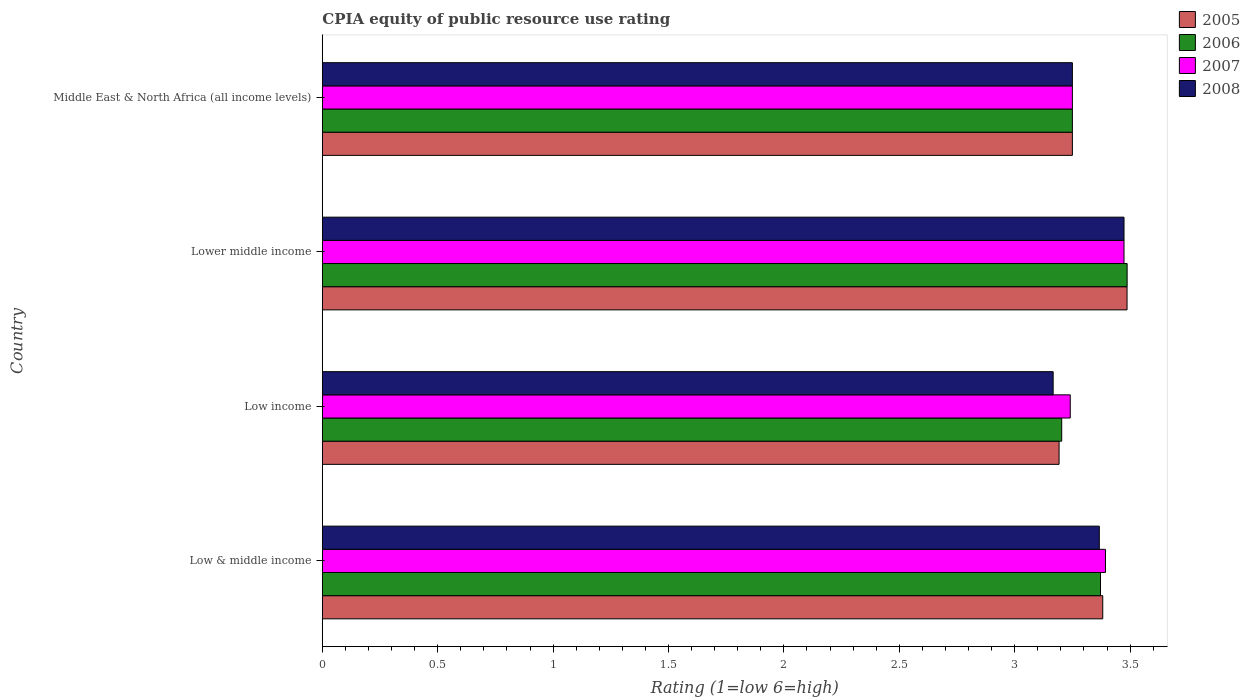How many groups of bars are there?
Provide a short and direct response. 4. Are the number of bars per tick equal to the number of legend labels?
Your answer should be compact. Yes. Are the number of bars on each tick of the Y-axis equal?
Ensure brevity in your answer.  Yes. How many bars are there on the 1st tick from the top?
Keep it short and to the point. 4. How many bars are there on the 3rd tick from the bottom?
Your answer should be very brief. 4. What is the label of the 4th group of bars from the top?
Ensure brevity in your answer.  Low & middle income. In how many cases, is the number of bars for a given country not equal to the number of legend labels?
Keep it short and to the point. 0. Across all countries, what is the maximum CPIA rating in 2007?
Your response must be concise. 3.47. Across all countries, what is the minimum CPIA rating in 2005?
Give a very brief answer. 3.19. In which country was the CPIA rating in 2006 maximum?
Keep it short and to the point. Lower middle income. What is the total CPIA rating in 2008 in the graph?
Provide a short and direct response. 13.26. What is the difference between the CPIA rating in 2006 in Lower middle income and that in Middle East & North Africa (all income levels)?
Make the answer very short. 0.24. What is the difference between the CPIA rating in 2005 in Lower middle income and the CPIA rating in 2006 in Low & middle income?
Keep it short and to the point. 0.12. What is the average CPIA rating in 2005 per country?
Ensure brevity in your answer.  3.33. What is the difference between the CPIA rating in 2008 and CPIA rating in 2006 in Low & middle income?
Keep it short and to the point. -0.01. What is the ratio of the CPIA rating in 2005 in Lower middle income to that in Middle East & North Africa (all income levels)?
Keep it short and to the point. 1.07. What is the difference between the highest and the second highest CPIA rating in 2007?
Provide a short and direct response. 0.08. What is the difference between the highest and the lowest CPIA rating in 2006?
Ensure brevity in your answer.  0.28. In how many countries, is the CPIA rating in 2008 greater than the average CPIA rating in 2008 taken over all countries?
Provide a short and direct response. 2. Is it the case that in every country, the sum of the CPIA rating in 2006 and CPIA rating in 2005 is greater than the sum of CPIA rating in 2007 and CPIA rating in 2008?
Offer a terse response. No. How many bars are there?
Ensure brevity in your answer.  16. What is the difference between two consecutive major ticks on the X-axis?
Your answer should be very brief. 0.5. Are the values on the major ticks of X-axis written in scientific E-notation?
Provide a succinct answer. No. Does the graph contain any zero values?
Your answer should be compact. No. Does the graph contain grids?
Make the answer very short. No. How are the legend labels stacked?
Provide a short and direct response. Vertical. What is the title of the graph?
Provide a short and direct response. CPIA equity of public resource use rating. Does "1979" appear as one of the legend labels in the graph?
Provide a succinct answer. No. What is the Rating (1=low 6=high) in 2005 in Low & middle income?
Give a very brief answer. 3.38. What is the Rating (1=low 6=high) in 2006 in Low & middle income?
Your response must be concise. 3.37. What is the Rating (1=low 6=high) of 2007 in Low & middle income?
Give a very brief answer. 3.39. What is the Rating (1=low 6=high) in 2008 in Low & middle income?
Your response must be concise. 3.37. What is the Rating (1=low 6=high) in 2005 in Low income?
Provide a succinct answer. 3.19. What is the Rating (1=low 6=high) in 2006 in Low income?
Offer a very short reply. 3.2. What is the Rating (1=low 6=high) of 2007 in Low income?
Provide a succinct answer. 3.24. What is the Rating (1=low 6=high) in 2008 in Low income?
Keep it short and to the point. 3.17. What is the Rating (1=low 6=high) in 2005 in Lower middle income?
Give a very brief answer. 3.49. What is the Rating (1=low 6=high) in 2006 in Lower middle income?
Ensure brevity in your answer.  3.49. What is the Rating (1=low 6=high) in 2007 in Lower middle income?
Offer a terse response. 3.47. What is the Rating (1=low 6=high) in 2008 in Lower middle income?
Make the answer very short. 3.47. What is the Rating (1=low 6=high) of 2005 in Middle East & North Africa (all income levels)?
Provide a short and direct response. 3.25. What is the Rating (1=low 6=high) in 2007 in Middle East & North Africa (all income levels)?
Provide a short and direct response. 3.25. Across all countries, what is the maximum Rating (1=low 6=high) in 2005?
Your answer should be very brief. 3.49. Across all countries, what is the maximum Rating (1=low 6=high) of 2006?
Offer a very short reply. 3.49. Across all countries, what is the maximum Rating (1=low 6=high) of 2007?
Offer a terse response. 3.47. Across all countries, what is the maximum Rating (1=low 6=high) in 2008?
Offer a terse response. 3.47. Across all countries, what is the minimum Rating (1=low 6=high) of 2005?
Give a very brief answer. 3.19. Across all countries, what is the minimum Rating (1=low 6=high) of 2006?
Give a very brief answer. 3.2. Across all countries, what is the minimum Rating (1=low 6=high) of 2007?
Your answer should be compact. 3.24. Across all countries, what is the minimum Rating (1=low 6=high) in 2008?
Offer a very short reply. 3.17. What is the total Rating (1=low 6=high) of 2005 in the graph?
Ensure brevity in your answer.  13.31. What is the total Rating (1=low 6=high) of 2006 in the graph?
Your answer should be compact. 13.31. What is the total Rating (1=low 6=high) of 2007 in the graph?
Offer a terse response. 13.36. What is the total Rating (1=low 6=high) of 2008 in the graph?
Offer a very short reply. 13.26. What is the difference between the Rating (1=low 6=high) of 2005 in Low & middle income and that in Low income?
Keep it short and to the point. 0.19. What is the difference between the Rating (1=low 6=high) in 2006 in Low & middle income and that in Low income?
Keep it short and to the point. 0.17. What is the difference between the Rating (1=low 6=high) in 2007 in Low & middle income and that in Low income?
Offer a terse response. 0.15. What is the difference between the Rating (1=low 6=high) of 2005 in Low & middle income and that in Lower middle income?
Offer a terse response. -0.11. What is the difference between the Rating (1=low 6=high) in 2006 in Low & middle income and that in Lower middle income?
Offer a terse response. -0.12. What is the difference between the Rating (1=low 6=high) of 2007 in Low & middle income and that in Lower middle income?
Make the answer very short. -0.08. What is the difference between the Rating (1=low 6=high) of 2008 in Low & middle income and that in Lower middle income?
Give a very brief answer. -0.11. What is the difference between the Rating (1=low 6=high) in 2005 in Low & middle income and that in Middle East & North Africa (all income levels)?
Offer a very short reply. 0.13. What is the difference between the Rating (1=low 6=high) in 2006 in Low & middle income and that in Middle East & North Africa (all income levels)?
Offer a terse response. 0.12. What is the difference between the Rating (1=low 6=high) of 2007 in Low & middle income and that in Middle East & North Africa (all income levels)?
Provide a succinct answer. 0.14. What is the difference between the Rating (1=low 6=high) of 2008 in Low & middle income and that in Middle East & North Africa (all income levels)?
Offer a terse response. 0.12. What is the difference between the Rating (1=low 6=high) in 2005 in Low income and that in Lower middle income?
Give a very brief answer. -0.29. What is the difference between the Rating (1=low 6=high) in 2006 in Low income and that in Lower middle income?
Make the answer very short. -0.28. What is the difference between the Rating (1=low 6=high) in 2007 in Low income and that in Lower middle income?
Provide a succinct answer. -0.23. What is the difference between the Rating (1=low 6=high) of 2008 in Low income and that in Lower middle income?
Your answer should be compact. -0.31. What is the difference between the Rating (1=low 6=high) in 2005 in Low income and that in Middle East & North Africa (all income levels)?
Offer a very short reply. -0.06. What is the difference between the Rating (1=low 6=high) of 2006 in Low income and that in Middle East & North Africa (all income levels)?
Ensure brevity in your answer.  -0.05. What is the difference between the Rating (1=low 6=high) in 2007 in Low income and that in Middle East & North Africa (all income levels)?
Provide a short and direct response. -0.01. What is the difference between the Rating (1=low 6=high) of 2008 in Low income and that in Middle East & North Africa (all income levels)?
Keep it short and to the point. -0.08. What is the difference between the Rating (1=low 6=high) in 2005 in Lower middle income and that in Middle East & North Africa (all income levels)?
Your response must be concise. 0.24. What is the difference between the Rating (1=low 6=high) of 2006 in Lower middle income and that in Middle East & North Africa (all income levels)?
Offer a terse response. 0.24. What is the difference between the Rating (1=low 6=high) of 2007 in Lower middle income and that in Middle East & North Africa (all income levels)?
Your answer should be compact. 0.22. What is the difference between the Rating (1=low 6=high) in 2008 in Lower middle income and that in Middle East & North Africa (all income levels)?
Provide a short and direct response. 0.22. What is the difference between the Rating (1=low 6=high) in 2005 in Low & middle income and the Rating (1=low 6=high) in 2006 in Low income?
Give a very brief answer. 0.18. What is the difference between the Rating (1=low 6=high) in 2005 in Low & middle income and the Rating (1=low 6=high) in 2007 in Low income?
Give a very brief answer. 0.14. What is the difference between the Rating (1=low 6=high) of 2005 in Low & middle income and the Rating (1=low 6=high) of 2008 in Low income?
Your answer should be compact. 0.21. What is the difference between the Rating (1=low 6=high) of 2006 in Low & middle income and the Rating (1=low 6=high) of 2007 in Low income?
Make the answer very short. 0.13. What is the difference between the Rating (1=low 6=high) in 2006 in Low & middle income and the Rating (1=low 6=high) in 2008 in Low income?
Keep it short and to the point. 0.21. What is the difference between the Rating (1=low 6=high) in 2007 in Low & middle income and the Rating (1=low 6=high) in 2008 in Low income?
Your answer should be very brief. 0.23. What is the difference between the Rating (1=low 6=high) in 2005 in Low & middle income and the Rating (1=low 6=high) in 2006 in Lower middle income?
Give a very brief answer. -0.11. What is the difference between the Rating (1=low 6=high) in 2005 in Low & middle income and the Rating (1=low 6=high) in 2007 in Lower middle income?
Give a very brief answer. -0.09. What is the difference between the Rating (1=low 6=high) of 2005 in Low & middle income and the Rating (1=low 6=high) of 2008 in Lower middle income?
Your response must be concise. -0.09. What is the difference between the Rating (1=low 6=high) of 2006 in Low & middle income and the Rating (1=low 6=high) of 2007 in Lower middle income?
Give a very brief answer. -0.1. What is the difference between the Rating (1=low 6=high) of 2006 in Low & middle income and the Rating (1=low 6=high) of 2008 in Lower middle income?
Keep it short and to the point. -0.1. What is the difference between the Rating (1=low 6=high) of 2007 in Low & middle income and the Rating (1=low 6=high) of 2008 in Lower middle income?
Offer a very short reply. -0.08. What is the difference between the Rating (1=low 6=high) of 2005 in Low & middle income and the Rating (1=low 6=high) of 2006 in Middle East & North Africa (all income levels)?
Offer a very short reply. 0.13. What is the difference between the Rating (1=low 6=high) of 2005 in Low & middle income and the Rating (1=low 6=high) of 2007 in Middle East & North Africa (all income levels)?
Offer a very short reply. 0.13. What is the difference between the Rating (1=low 6=high) in 2005 in Low & middle income and the Rating (1=low 6=high) in 2008 in Middle East & North Africa (all income levels)?
Your response must be concise. 0.13. What is the difference between the Rating (1=low 6=high) of 2006 in Low & middle income and the Rating (1=low 6=high) of 2007 in Middle East & North Africa (all income levels)?
Ensure brevity in your answer.  0.12. What is the difference between the Rating (1=low 6=high) in 2006 in Low & middle income and the Rating (1=low 6=high) in 2008 in Middle East & North Africa (all income levels)?
Your answer should be compact. 0.12. What is the difference between the Rating (1=low 6=high) in 2007 in Low & middle income and the Rating (1=low 6=high) in 2008 in Middle East & North Africa (all income levels)?
Make the answer very short. 0.14. What is the difference between the Rating (1=low 6=high) in 2005 in Low income and the Rating (1=low 6=high) in 2006 in Lower middle income?
Your answer should be compact. -0.29. What is the difference between the Rating (1=low 6=high) in 2005 in Low income and the Rating (1=low 6=high) in 2007 in Lower middle income?
Offer a very short reply. -0.28. What is the difference between the Rating (1=low 6=high) of 2005 in Low income and the Rating (1=low 6=high) of 2008 in Lower middle income?
Give a very brief answer. -0.28. What is the difference between the Rating (1=low 6=high) of 2006 in Low income and the Rating (1=low 6=high) of 2007 in Lower middle income?
Your answer should be compact. -0.27. What is the difference between the Rating (1=low 6=high) of 2006 in Low income and the Rating (1=low 6=high) of 2008 in Lower middle income?
Offer a very short reply. -0.27. What is the difference between the Rating (1=low 6=high) of 2007 in Low income and the Rating (1=low 6=high) of 2008 in Lower middle income?
Keep it short and to the point. -0.23. What is the difference between the Rating (1=low 6=high) in 2005 in Low income and the Rating (1=low 6=high) in 2006 in Middle East & North Africa (all income levels)?
Keep it short and to the point. -0.06. What is the difference between the Rating (1=low 6=high) of 2005 in Low income and the Rating (1=low 6=high) of 2007 in Middle East & North Africa (all income levels)?
Provide a succinct answer. -0.06. What is the difference between the Rating (1=low 6=high) in 2005 in Low income and the Rating (1=low 6=high) in 2008 in Middle East & North Africa (all income levels)?
Offer a terse response. -0.06. What is the difference between the Rating (1=low 6=high) of 2006 in Low income and the Rating (1=low 6=high) of 2007 in Middle East & North Africa (all income levels)?
Provide a short and direct response. -0.05. What is the difference between the Rating (1=low 6=high) in 2006 in Low income and the Rating (1=low 6=high) in 2008 in Middle East & North Africa (all income levels)?
Offer a very short reply. -0.05. What is the difference between the Rating (1=low 6=high) of 2007 in Low income and the Rating (1=low 6=high) of 2008 in Middle East & North Africa (all income levels)?
Offer a very short reply. -0.01. What is the difference between the Rating (1=low 6=high) in 2005 in Lower middle income and the Rating (1=low 6=high) in 2006 in Middle East & North Africa (all income levels)?
Provide a succinct answer. 0.24. What is the difference between the Rating (1=low 6=high) of 2005 in Lower middle income and the Rating (1=low 6=high) of 2007 in Middle East & North Africa (all income levels)?
Your answer should be very brief. 0.24. What is the difference between the Rating (1=low 6=high) in 2005 in Lower middle income and the Rating (1=low 6=high) in 2008 in Middle East & North Africa (all income levels)?
Keep it short and to the point. 0.24. What is the difference between the Rating (1=low 6=high) of 2006 in Lower middle income and the Rating (1=low 6=high) of 2007 in Middle East & North Africa (all income levels)?
Make the answer very short. 0.24. What is the difference between the Rating (1=low 6=high) of 2006 in Lower middle income and the Rating (1=low 6=high) of 2008 in Middle East & North Africa (all income levels)?
Make the answer very short. 0.24. What is the difference between the Rating (1=low 6=high) of 2007 in Lower middle income and the Rating (1=low 6=high) of 2008 in Middle East & North Africa (all income levels)?
Keep it short and to the point. 0.22. What is the average Rating (1=low 6=high) in 2005 per country?
Provide a succinct answer. 3.33. What is the average Rating (1=low 6=high) of 2006 per country?
Keep it short and to the point. 3.33. What is the average Rating (1=low 6=high) in 2007 per country?
Offer a very short reply. 3.34. What is the average Rating (1=low 6=high) in 2008 per country?
Keep it short and to the point. 3.31. What is the difference between the Rating (1=low 6=high) of 2005 and Rating (1=low 6=high) of 2006 in Low & middle income?
Keep it short and to the point. 0.01. What is the difference between the Rating (1=low 6=high) in 2005 and Rating (1=low 6=high) in 2007 in Low & middle income?
Offer a terse response. -0.01. What is the difference between the Rating (1=low 6=high) in 2005 and Rating (1=low 6=high) in 2008 in Low & middle income?
Offer a terse response. 0.01. What is the difference between the Rating (1=low 6=high) of 2006 and Rating (1=low 6=high) of 2007 in Low & middle income?
Offer a terse response. -0.02. What is the difference between the Rating (1=low 6=high) in 2006 and Rating (1=low 6=high) in 2008 in Low & middle income?
Offer a terse response. 0.01. What is the difference between the Rating (1=low 6=high) in 2007 and Rating (1=low 6=high) in 2008 in Low & middle income?
Give a very brief answer. 0.03. What is the difference between the Rating (1=low 6=high) of 2005 and Rating (1=low 6=high) of 2006 in Low income?
Your response must be concise. -0.01. What is the difference between the Rating (1=low 6=high) of 2005 and Rating (1=low 6=high) of 2007 in Low income?
Provide a succinct answer. -0.05. What is the difference between the Rating (1=low 6=high) in 2005 and Rating (1=low 6=high) in 2008 in Low income?
Ensure brevity in your answer.  0.03. What is the difference between the Rating (1=low 6=high) of 2006 and Rating (1=low 6=high) of 2007 in Low income?
Provide a succinct answer. -0.04. What is the difference between the Rating (1=low 6=high) in 2006 and Rating (1=low 6=high) in 2008 in Low income?
Provide a succinct answer. 0.04. What is the difference between the Rating (1=low 6=high) in 2007 and Rating (1=low 6=high) in 2008 in Low income?
Provide a short and direct response. 0.07. What is the difference between the Rating (1=low 6=high) in 2005 and Rating (1=low 6=high) in 2006 in Lower middle income?
Keep it short and to the point. -0. What is the difference between the Rating (1=low 6=high) in 2005 and Rating (1=low 6=high) in 2007 in Lower middle income?
Your response must be concise. 0.01. What is the difference between the Rating (1=low 6=high) in 2005 and Rating (1=low 6=high) in 2008 in Lower middle income?
Your response must be concise. 0.01. What is the difference between the Rating (1=low 6=high) of 2006 and Rating (1=low 6=high) of 2007 in Lower middle income?
Offer a very short reply. 0.01. What is the difference between the Rating (1=low 6=high) of 2006 and Rating (1=low 6=high) of 2008 in Lower middle income?
Provide a succinct answer. 0.01. What is the difference between the Rating (1=low 6=high) of 2005 and Rating (1=low 6=high) of 2007 in Middle East & North Africa (all income levels)?
Your response must be concise. 0. What is the difference between the Rating (1=low 6=high) in 2005 and Rating (1=low 6=high) in 2008 in Middle East & North Africa (all income levels)?
Offer a very short reply. 0. What is the difference between the Rating (1=low 6=high) in 2006 and Rating (1=low 6=high) in 2008 in Middle East & North Africa (all income levels)?
Your answer should be compact. 0. What is the difference between the Rating (1=low 6=high) in 2007 and Rating (1=low 6=high) in 2008 in Middle East & North Africa (all income levels)?
Give a very brief answer. 0. What is the ratio of the Rating (1=low 6=high) of 2005 in Low & middle income to that in Low income?
Keep it short and to the point. 1.06. What is the ratio of the Rating (1=low 6=high) in 2006 in Low & middle income to that in Low income?
Provide a short and direct response. 1.05. What is the ratio of the Rating (1=low 6=high) in 2007 in Low & middle income to that in Low income?
Make the answer very short. 1.05. What is the ratio of the Rating (1=low 6=high) in 2008 in Low & middle income to that in Low income?
Keep it short and to the point. 1.06. What is the ratio of the Rating (1=low 6=high) in 2005 in Low & middle income to that in Lower middle income?
Provide a short and direct response. 0.97. What is the ratio of the Rating (1=low 6=high) in 2006 in Low & middle income to that in Lower middle income?
Your answer should be compact. 0.97. What is the ratio of the Rating (1=low 6=high) of 2007 in Low & middle income to that in Lower middle income?
Ensure brevity in your answer.  0.98. What is the ratio of the Rating (1=low 6=high) in 2008 in Low & middle income to that in Lower middle income?
Offer a terse response. 0.97. What is the ratio of the Rating (1=low 6=high) of 2005 in Low & middle income to that in Middle East & North Africa (all income levels)?
Give a very brief answer. 1.04. What is the ratio of the Rating (1=low 6=high) of 2006 in Low & middle income to that in Middle East & North Africa (all income levels)?
Provide a short and direct response. 1.04. What is the ratio of the Rating (1=low 6=high) in 2007 in Low & middle income to that in Middle East & North Africa (all income levels)?
Keep it short and to the point. 1.04. What is the ratio of the Rating (1=low 6=high) of 2008 in Low & middle income to that in Middle East & North Africa (all income levels)?
Offer a terse response. 1.04. What is the ratio of the Rating (1=low 6=high) in 2005 in Low income to that in Lower middle income?
Your answer should be very brief. 0.92. What is the ratio of the Rating (1=low 6=high) in 2006 in Low income to that in Lower middle income?
Provide a short and direct response. 0.92. What is the ratio of the Rating (1=low 6=high) in 2007 in Low income to that in Lower middle income?
Offer a terse response. 0.93. What is the ratio of the Rating (1=low 6=high) of 2008 in Low income to that in Lower middle income?
Provide a succinct answer. 0.91. What is the ratio of the Rating (1=low 6=high) in 2005 in Low income to that in Middle East & North Africa (all income levels)?
Provide a short and direct response. 0.98. What is the ratio of the Rating (1=low 6=high) of 2006 in Low income to that in Middle East & North Africa (all income levels)?
Give a very brief answer. 0.99. What is the ratio of the Rating (1=low 6=high) in 2008 in Low income to that in Middle East & North Africa (all income levels)?
Provide a short and direct response. 0.97. What is the ratio of the Rating (1=low 6=high) of 2005 in Lower middle income to that in Middle East & North Africa (all income levels)?
Keep it short and to the point. 1.07. What is the ratio of the Rating (1=low 6=high) of 2006 in Lower middle income to that in Middle East & North Africa (all income levels)?
Give a very brief answer. 1.07. What is the ratio of the Rating (1=low 6=high) in 2007 in Lower middle income to that in Middle East & North Africa (all income levels)?
Provide a short and direct response. 1.07. What is the ratio of the Rating (1=low 6=high) in 2008 in Lower middle income to that in Middle East & North Africa (all income levels)?
Offer a terse response. 1.07. What is the difference between the highest and the second highest Rating (1=low 6=high) of 2005?
Offer a very short reply. 0.11. What is the difference between the highest and the second highest Rating (1=low 6=high) in 2006?
Your answer should be compact. 0.12. What is the difference between the highest and the second highest Rating (1=low 6=high) in 2007?
Offer a terse response. 0.08. What is the difference between the highest and the second highest Rating (1=low 6=high) in 2008?
Your answer should be very brief. 0.11. What is the difference between the highest and the lowest Rating (1=low 6=high) in 2005?
Provide a short and direct response. 0.29. What is the difference between the highest and the lowest Rating (1=low 6=high) of 2006?
Give a very brief answer. 0.28. What is the difference between the highest and the lowest Rating (1=low 6=high) of 2007?
Make the answer very short. 0.23. What is the difference between the highest and the lowest Rating (1=low 6=high) in 2008?
Your response must be concise. 0.31. 